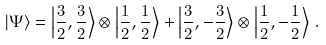Convert formula to latex. <formula><loc_0><loc_0><loc_500><loc_500>| \Psi \rangle = \left | \frac { 3 } { 2 } , \frac { 3 } { 2 } \right \rangle \otimes \left | \frac { 1 } { 2 } , \frac { 1 } { 2 } \right \rangle + \left | \frac { 3 } { 2 } , - \frac { 3 } { 2 } \right \rangle \otimes \left | \frac { 1 } { 2 } , - \frac { 1 } { 2 } \right \rangle \, .</formula> 